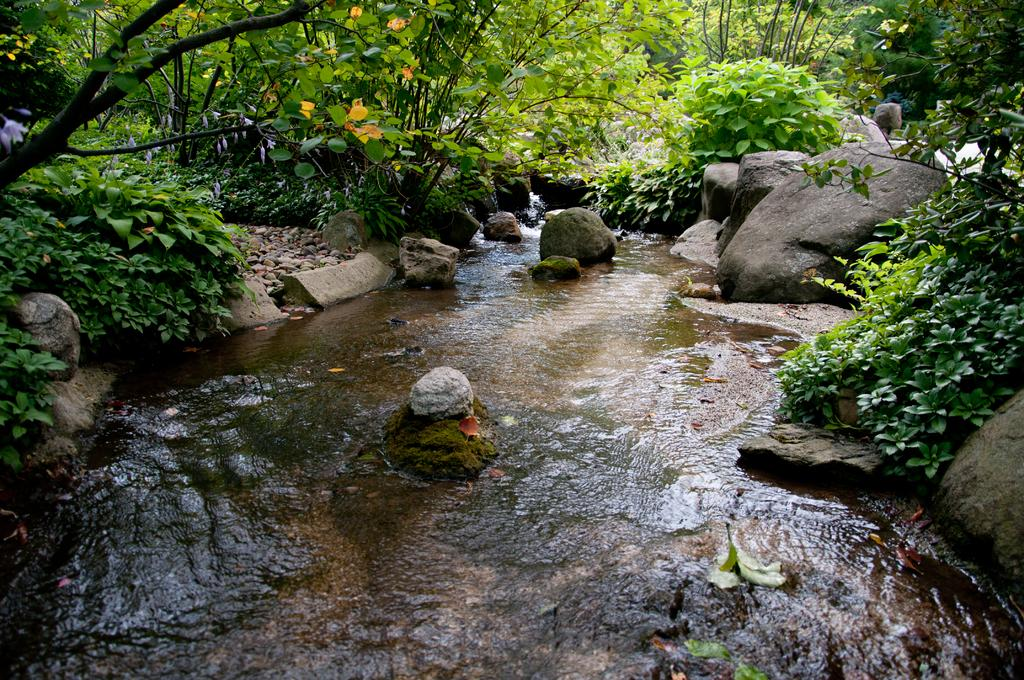What type of natural elements can be seen in the image? There are trees and water flowing in the image. What other objects can be observed in the image? There are rocks visible in the image. What type of drum is being played in the image? There is no drum present in the image; it features trees, water, and rocks. What is the condition of the fact in the image? There is no fact or condition mentioned in the image; it only contains natural elements and objects. 